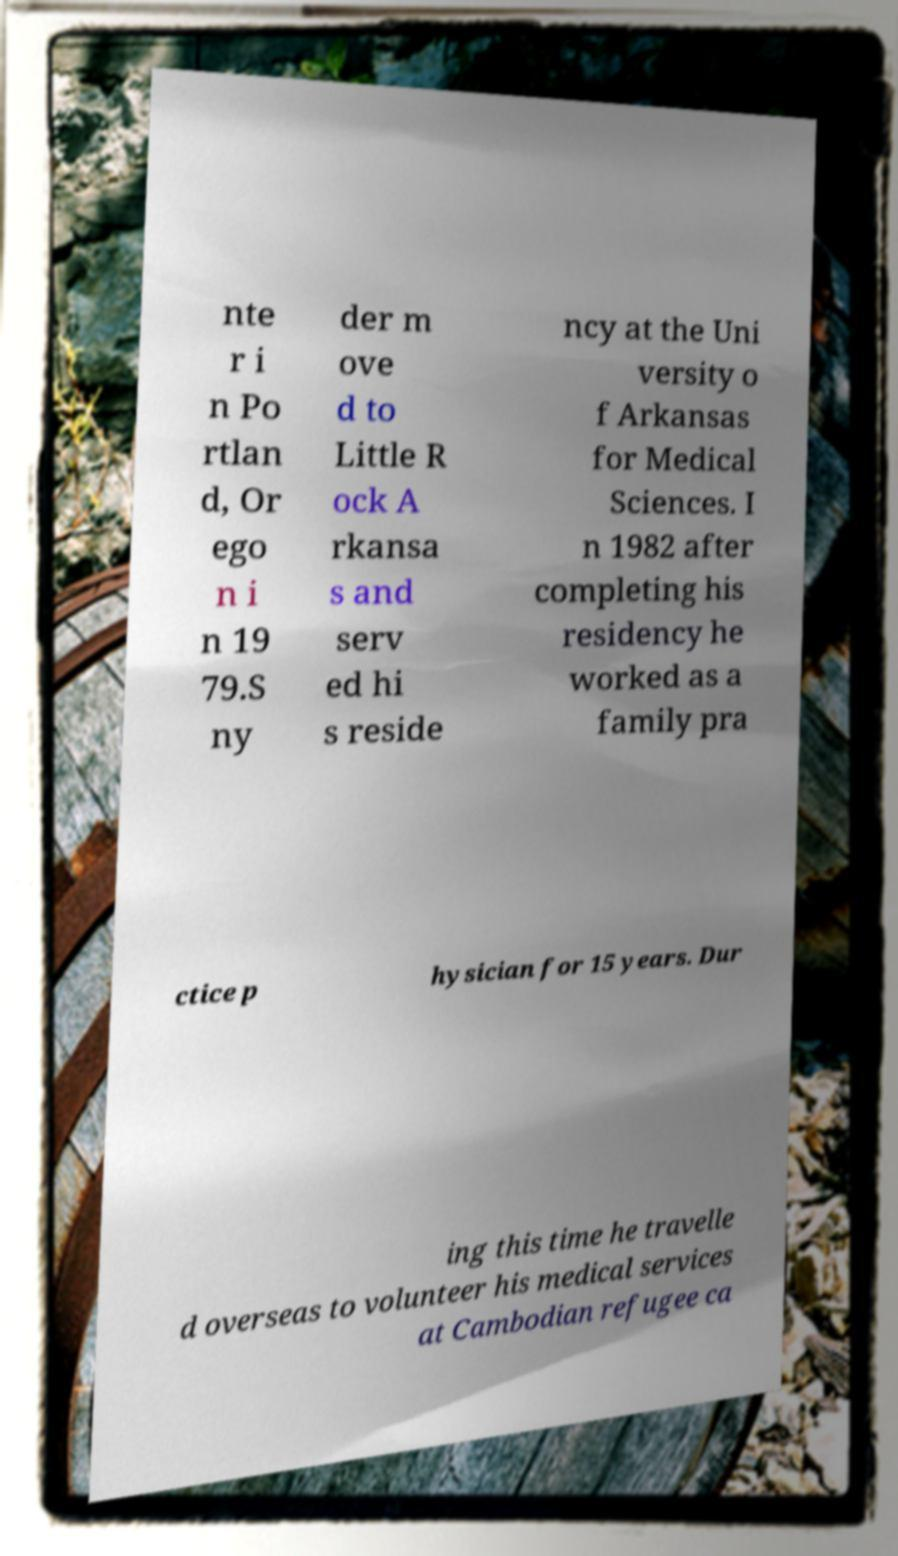There's text embedded in this image that I need extracted. Can you transcribe it verbatim? nte r i n Po rtlan d, Or ego n i n 19 79.S ny der m ove d to Little R ock A rkansa s and serv ed hi s reside ncy at the Uni versity o f Arkansas for Medical Sciences. I n 1982 after completing his residency he worked as a family pra ctice p hysician for 15 years. Dur ing this time he travelle d overseas to volunteer his medical services at Cambodian refugee ca 